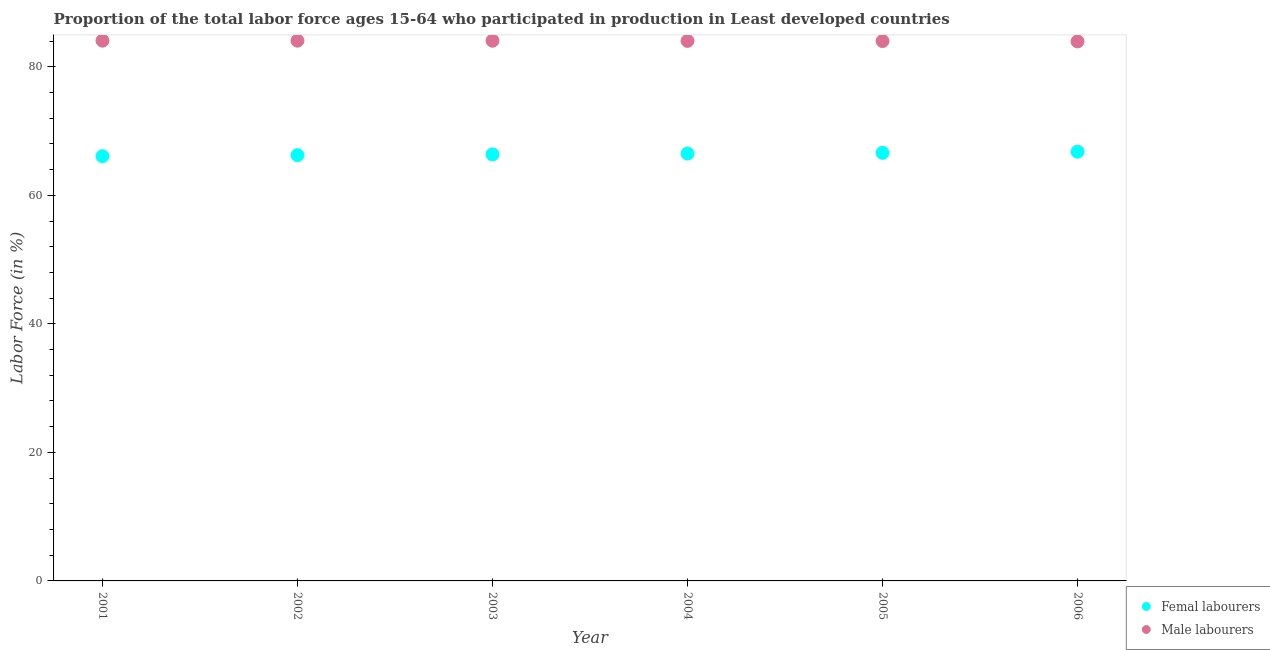What is the percentage of female labor force in 2005?
Your response must be concise. 66.62. Across all years, what is the maximum percentage of male labour force?
Provide a succinct answer. 84.07. Across all years, what is the minimum percentage of female labor force?
Provide a succinct answer. 66.1. In which year was the percentage of female labor force maximum?
Provide a succinct answer. 2006. What is the total percentage of male labour force in the graph?
Give a very brief answer. 504.22. What is the difference between the percentage of male labour force in 2001 and that in 2002?
Give a very brief answer. 0. What is the difference between the percentage of female labor force in 2001 and the percentage of male labour force in 2002?
Your response must be concise. -17.98. What is the average percentage of female labor force per year?
Keep it short and to the point. 66.44. In the year 2004, what is the difference between the percentage of male labour force and percentage of female labor force?
Make the answer very short. 17.54. What is the ratio of the percentage of male labour force in 2001 to that in 2006?
Ensure brevity in your answer.  1. Is the percentage of male labour force in 2003 less than that in 2006?
Your response must be concise. No. What is the difference between the highest and the second highest percentage of female labor force?
Offer a terse response. 0.18. What is the difference between the highest and the lowest percentage of female labor force?
Provide a succinct answer. 0.7. Is the sum of the percentage of female labor force in 2001 and 2005 greater than the maximum percentage of male labour force across all years?
Provide a short and direct response. Yes. Does the percentage of male labour force monotonically increase over the years?
Provide a succinct answer. No. Is the percentage of female labor force strictly greater than the percentage of male labour force over the years?
Your response must be concise. No. How many dotlines are there?
Keep it short and to the point. 2. Does the graph contain grids?
Provide a succinct answer. No. Where does the legend appear in the graph?
Your response must be concise. Bottom right. How many legend labels are there?
Your answer should be very brief. 2. What is the title of the graph?
Make the answer very short. Proportion of the total labor force ages 15-64 who participated in production in Least developed countries. Does "Number of departures" appear as one of the legend labels in the graph?
Keep it short and to the point. No. What is the label or title of the X-axis?
Provide a succinct answer. Year. What is the label or title of the Y-axis?
Offer a very short reply. Labor Force (in %). What is the Labor Force (in %) in Femal labourers in 2001?
Offer a very short reply. 66.1. What is the Labor Force (in %) in Male labourers in 2001?
Your answer should be very brief. 84.07. What is the Labor Force (in %) in Femal labourers in 2002?
Your response must be concise. 66.26. What is the Labor Force (in %) of Male labourers in 2002?
Keep it short and to the point. 84.07. What is the Labor Force (in %) of Femal labourers in 2003?
Offer a very short reply. 66.37. What is the Labor Force (in %) of Male labourers in 2003?
Offer a very short reply. 84.06. What is the Labor Force (in %) of Femal labourers in 2004?
Provide a succinct answer. 66.5. What is the Labor Force (in %) in Male labourers in 2004?
Your answer should be compact. 84.04. What is the Labor Force (in %) of Femal labourers in 2005?
Provide a short and direct response. 66.62. What is the Labor Force (in %) of Male labourers in 2005?
Ensure brevity in your answer.  84.01. What is the Labor Force (in %) in Femal labourers in 2006?
Ensure brevity in your answer.  66.8. What is the Labor Force (in %) of Male labourers in 2006?
Make the answer very short. 83.96. Across all years, what is the maximum Labor Force (in %) in Femal labourers?
Your answer should be compact. 66.8. Across all years, what is the maximum Labor Force (in %) in Male labourers?
Your answer should be very brief. 84.07. Across all years, what is the minimum Labor Force (in %) in Femal labourers?
Offer a terse response. 66.1. Across all years, what is the minimum Labor Force (in %) in Male labourers?
Offer a terse response. 83.96. What is the total Labor Force (in %) of Femal labourers in the graph?
Give a very brief answer. 398.64. What is the total Labor Force (in %) in Male labourers in the graph?
Provide a short and direct response. 504.22. What is the difference between the Labor Force (in %) in Femal labourers in 2001 and that in 2002?
Your answer should be very brief. -0.16. What is the difference between the Labor Force (in %) in Male labourers in 2001 and that in 2002?
Your answer should be compact. 0. What is the difference between the Labor Force (in %) in Femal labourers in 2001 and that in 2003?
Provide a short and direct response. -0.27. What is the difference between the Labor Force (in %) of Male labourers in 2001 and that in 2003?
Your answer should be compact. 0.01. What is the difference between the Labor Force (in %) of Femal labourers in 2001 and that in 2004?
Give a very brief answer. -0.4. What is the difference between the Labor Force (in %) in Male labourers in 2001 and that in 2004?
Provide a short and direct response. 0.04. What is the difference between the Labor Force (in %) of Femal labourers in 2001 and that in 2005?
Provide a succinct answer. -0.52. What is the difference between the Labor Force (in %) of Male labourers in 2001 and that in 2005?
Make the answer very short. 0.06. What is the difference between the Labor Force (in %) of Femal labourers in 2001 and that in 2006?
Your answer should be compact. -0.7. What is the difference between the Labor Force (in %) of Male labourers in 2001 and that in 2006?
Make the answer very short. 0.12. What is the difference between the Labor Force (in %) in Femal labourers in 2002 and that in 2003?
Make the answer very short. -0.11. What is the difference between the Labor Force (in %) in Femal labourers in 2002 and that in 2004?
Offer a very short reply. -0.24. What is the difference between the Labor Force (in %) in Male labourers in 2002 and that in 2004?
Provide a short and direct response. 0.04. What is the difference between the Labor Force (in %) of Femal labourers in 2002 and that in 2005?
Ensure brevity in your answer.  -0.36. What is the difference between the Labor Force (in %) of Male labourers in 2002 and that in 2005?
Give a very brief answer. 0.06. What is the difference between the Labor Force (in %) of Femal labourers in 2002 and that in 2006?
Offer a very short reply. -0.54. What is the difference between the Labor Force (in %) of Male labourers in 2002 and that in 2006?
Ensure brevity in your answer.  0.12. What is the difference between the Labor Force (in %) in Femal labourers in 2003 and that in 2004?
Your response must be concise. -0.13. What is the difference between the Labor Force (in %) in Male labourers in 2003 and that in 2004?
Offer a terse response. 0.03. What is the difference between the Labor Force (in %) of Femal labourers in 2003 and that in 2005?
Give a very brief answer. -0.25. What is the difference between the Labor Force (in %) of Male labourers in 2003 and that in 2005?
Provide a succinct answer. 0.05. What is the difference between the Labor Force (in %) of Femal labourers in 2003 and that in 2006?
Your answer should be compact. -0.43. What is the difference between the Labor Force (in %) in Male labourers in 2003 and that in 2006?
Offer a terse response. 0.11. What is the difference between the Labor Force (in %) in Femal labourers in 2004 and that in 2005?
Ensure brevity in your answer.  -0.12. What is the difference between the Labor Force (in %) in Male labourers in 2004 and that in 2005?
Your answer should be very brief. 0.02. What is the difference between the Labor Force (in %) of Femal labourers in 2004 and that in 2006?
Your answer should be compact. -0.3. What is the difference between the Labor Force (in %) in Male labourers in 2004 and that in 2006?
Your answer should be compact. 0.08. What is the difference between the Labor Force (in %) of Femal labourers in 2005 and that in 2006?
Ensure brevity in your answer.  -0.18. What is the difference between the Labor Force (in %) of Male labourers in 2005 and that in 2006?
Keep it short and to the point. 0.06. What is the difference between the Labor Force (in %) in Femal labourers in 2001 and the Labor Force (in %) in Male labourers in 2002?
Provide a short and direct response. -17.98. What is the difference between the Labor Force (in %) of Femal labourers in 2001 and the Labor Force (in %) of Male labourers in 2003?
Your answer should be very brief. -17.97. What is the difference between the Labor Force (in %) of Femal labourers in 2001 and the Labor Force (in %) of Male labourers in 2004?
Ensure brevity in your answer.  -17.94. What is the difference between the Labor Force (in %) of Femal labourers in 2001 and the Labor Force (in %) of Male labourers in 2005?
Your answer should be compact. -17.91. What is the difference between the Labor Force (in %) in Femal labourers in 2001 and the Labor Force (in %) in Male labourers in 2006?
Ensure brevity in your answer.  -17.86. What is the difference between the Labor Force (in %) in Femal labourers in 2002 and the Labor Force (in %) in Male labourers in 2003?
Your response must be concise. -17.8. What is the difference between the Labor Force (in %) of Femal labourers in 2002 and the Labor Force (in %) of Male labourers in 2004?
Offer a very short reply. -17.78. What is the difference between the Labor Force (in %) of Femal labourers in 2002 and the Labor Force (in %) of Male labourers in 2005?
Offer a very short reply. -17.75. What is the difference between the Labor Force (in %) in Femal labourers in 2002 and the Labor Force (in %) in Male labourers in 2006?
Keep it short and to the point. -17.7. What is the difference between the Labor Force (in %) in Femal labourers in 2003 and the Labor Force (in %) in Male labourers in 2004?
Give a very brief answer. -17.66. What is the difference between the Labor Force (in %) of Femal labourers in 2003 and the Labor Force (in %) of Male labourers in 2005?
Provide a succinct answer. -17.64. What is the difference between the Labor Force (in %) in Femal labourers in 2003 and the Labor Force (in %) in Male labourers in 2006?
Your answer should be compact. -17.58. What is the difference between the Labor Force (in %) of Femal labourers in 2004 and the Labor Force (in %) of Male labourers in 2005?
Provide a short and direct response. -17.51. What is the difference between the Labor Force (in %) of Femal labourers in 2004 and the Labor Force (in %) of Male labourers in 2006?
Provide a succinct answer. -17.46. What is the difference between the Labor Force (in %) in Femal labourers in 2005 and the Labor Force (in %) in Male labourers in 2006?
Your answer should be compact. -17.34. What is the average Labor Force (in %) of Femal labourers per year?
Your answer should be very brief. 66.44. What is the average Labor Force (in %) of Male labourers per year?
Make the answer very short. 84.04. In the year 2001, what is the difference between the Labor Force (in %) in Femal labourers and Labor Force (in %) in Male labourers?
Make the answer very short. -17.98. In the year 2002, what is the difference between the Labor Force (in %) in Femal labourers and Labor Force (in %) in Male labourers?
Provide a short and direct response. -17.81. In the year 2003, what is the difference between the Labor Force (in %) of Femal labourers and Labor Force (in %) of Male labourers?
Your response must be concise. -17.69. In the year 2004, what is the difference between the Labor Force (in %) of Femal labourers and Labor Force (in %) of Male labourers?
Keep it short and to the point. -17.54. In the year 2005, what is the difference between the Labor Force (in %) of Femal labourers and Labor Force (in %) of Male labourers?
Provide a short and direct response. -17.39. In the year 2006, what is the difference between the Labor Force (in %) of Femal labourers and Labor Force (in %) of Male labourers?
Ensure brevity in your answer.  -17.16. What is the ratio of the Labor Force (in %) in Male labourers in 2001 to that in 2002?
Give a very brief answer. 1. What is the ratio of the Labor Force (in %) in Male labourers in 2001 to that in 2003?
Keep it short and to the point. 1. What is the ratio of the Labor Force (in %) in Femal labourers in 2001 to that in 2006?
Your response must be concise. 0.99. What is the ratio of the Labor Force (in %) of Male labourers in 2002 to that in 2003?
Your answer should be compact. 1. What is the ratio of the Labor Force (in %) of Male labourers in 2003 to that in 2004?
Provide a short and direct response. 1. What is the ratio of the Labor Force (in %) in Femal labourers in 2003 to that in 2005?
Your answer should be very brief. 1. What is the ratio of the Labor Force (in %) of Femal labourers in 2004 to that in 2006?
Offer a terse response. 1. What is the difference between the highest and the second highest Labor Force (in %) of Femal labourers?
Provide a short and direct response. 0.18. What is the difference between the highest and the second highest Labor Force (in %) of Male labourers?
Your answer should be very brief. 0. What is the difference between the highest and the lowest Labor Force (in %) in Femal labourers?
Your response must be concise. 0.7. What is the difference between the highest and the lowest Labor Force (in %) of Male labourers?
Make the answer very short. 0.12. 